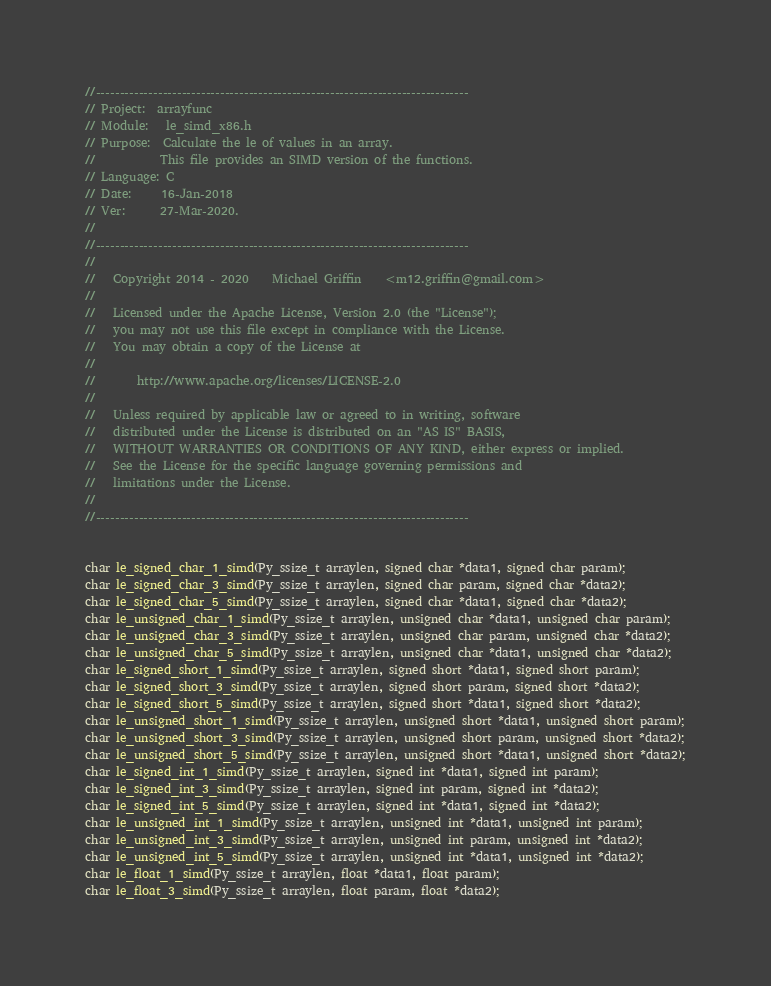<code> <loc_0><loc_0><loc_500><loc_500><_C_>//------------------------------------------------------------------------------
// Project:  arrayfunc
// Module:   le_simd_x86.h
// Purpose:  Calculate the le of values in an array.
//           This file provides an SIMD version of the functions.
// Language: C
// Date:     16-Jan-2018
// Ver:      27-Mar-2020.
//
//------------------------------------------------------------------------------
//
//   Copyright 2014 - 2020    Michael Griffin    <m12.griffin@gmail.com>
//
//   Licensed under the Apache License, Version 2.0 (the "License");
//   you may not use this file except in compliance with the License.
//   You may obtain a copy of the License at
//
//       http://www.apache.org/licenses/LICENSE-2.0
//
//   Unless required by applicable law or agreed to in writing, software
//   distributed under the License is distributed on an "AS IS" BASIS,
//   WITHOUT WARRANTIES OR CONDITIONS OF ANY KIND, either express or implied.
//   See the License for the specific language governing permissions and
//   limitations under the License.
//
//------------------------------------------------------------------------------


char le_signed_char_1_simd(Py_ssize_t arraylen, signed char *data1, signed char param);
char le_signed_char_3_simd(Py_ssize_t arraylen, signed char param, signed char *data2);
char le_signed_char_5_simd(Py_ssize_t arraylen, signed char *data1, signed char *data2);
char le_unsigned_char_1_simd(Py_ssize_t arraylen, unsigned char *data1, unsigned char param);
char le_unsigned_char_3_simd(Py_ssize_t arraylen, unsigned char param, unsigned char *data2);
char le_unsigned_char_5_simd(Py_ssize_t arraylen, unsigned char *data1, unsigned char *data2);
char le_signed_short_1_simd(Py_ssize_t arraylen, signed short *data1, signed short param);
char le_signed_short_3_simd(Py_ssize_t arraylen, signed short param, signed short *data2);
char le_signed_short_5_simd(Py_ssize_t arraylen, signed short *data1, signed short *data2);
char le_unsigned_short_1_simd(Py_ssize_t arraylen, unsigned short *data1, unsigned short param);
char le_unsigned_short_3_simd(Py_ssize_t arraylen, unsigned short param, unsigned short *data2);
char le_unsigned_short_5_simd(Py_ssize_t arraylen, unsigned short *data1, unsigned short *data2);
char le_signed_int_1_simd(Py_ssize_t arraylen, signed int *data1, signed int param);
char le_signed_int_3_simd(Py_ssize_t arraylen, signed int param, signed int *data2);
char le_signed_int_5_simd(Py_ssize_t arraylen, signed int *data1, signed int *data2);
char le_unsigned_int_1_simd(Py_ssize_t arraylen, unsigned int *data1, unsigned int param);
char le_unsigned_int_3_simd(Py_ssize_t arraylen, unsigned int param, unsigned int *data2);
char le_unsigned_int_5_simd(Py_ssize_t arraylen, unsigned int *data1, unsigned int *data2);
char le_float_1_simd(Py_ssize_t arraylen, float *data1, float param);
char le_float_3_simd(Py_ssize_t arraylen, float param, float *data2);</code> 